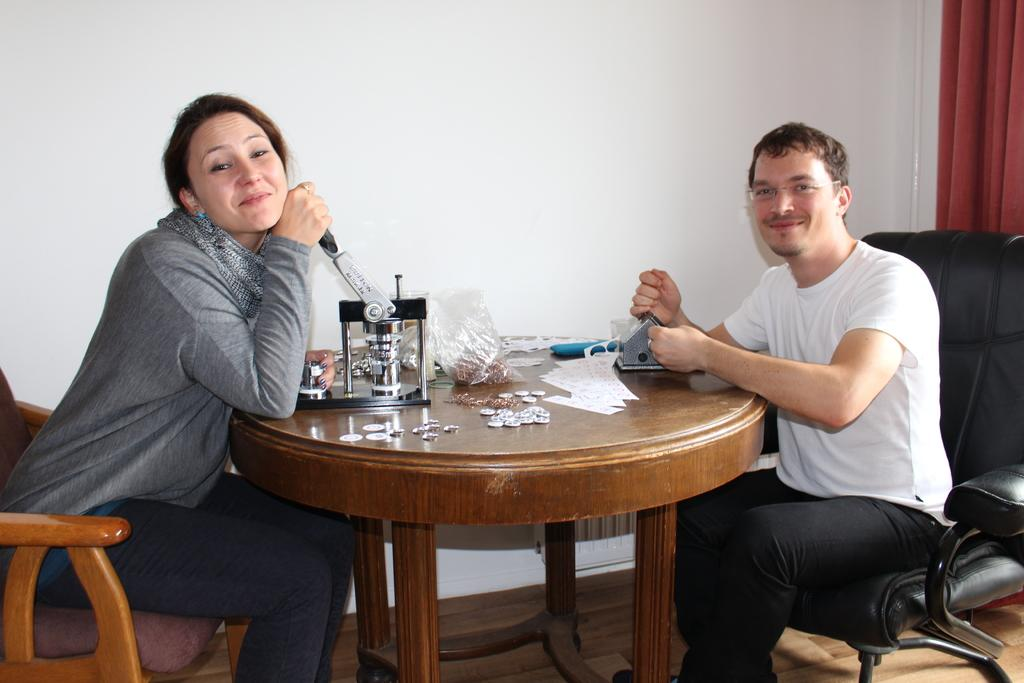Who is present in the image? There is a couple in the image. What are the couple doing in the image? The couple is posing for a camera and performing a cutting and pressing action. Where are the couple sitting in the image? The couple is sitting at a table. What type of nut is the grandfather cracking in the image? There is no grandfather or nut present in the image. 